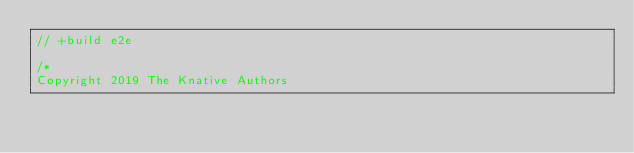<code> <loc_0><loc_0><loc_500><loc_500><_Go_>// +build e2e

/*
Copyright 2019 The Knative Authors
</code> 